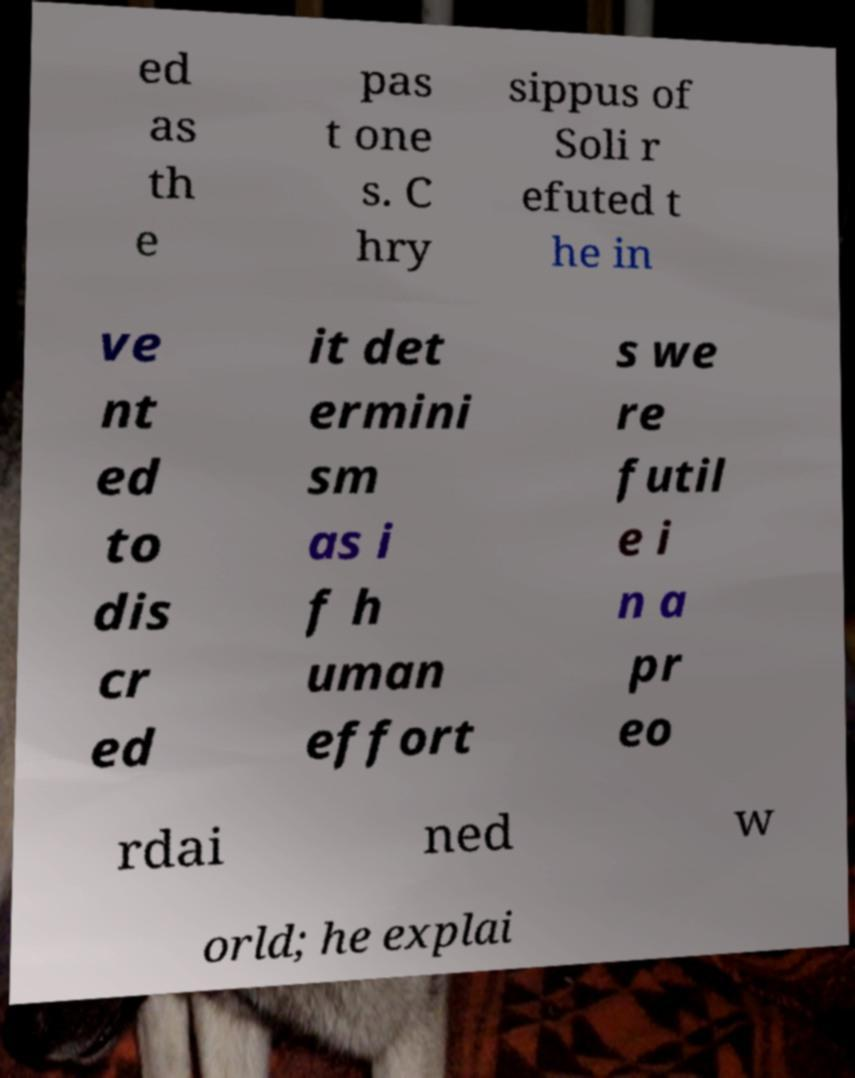Could you extract and type out the text from this image? ed as th e pas t one s. C hry sippus of Soli r efuted t he in ve nt ed to dis cr ed it det ermini sm as i f h uman effort s we re futil e i n a pr eo rdai ned w orld; he explai 